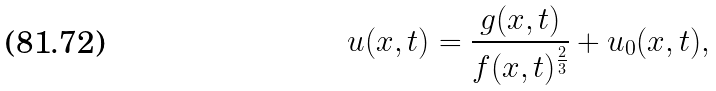<formula> <loc_0><loc_0><loc_500><loc_500>u ( x , t ) = \frac { g ( x , t ) } { f ( x , t ) ^ { \frac { 2 } { 3 } } } + u _ { 0 } ( x , t ) ,</formula> 